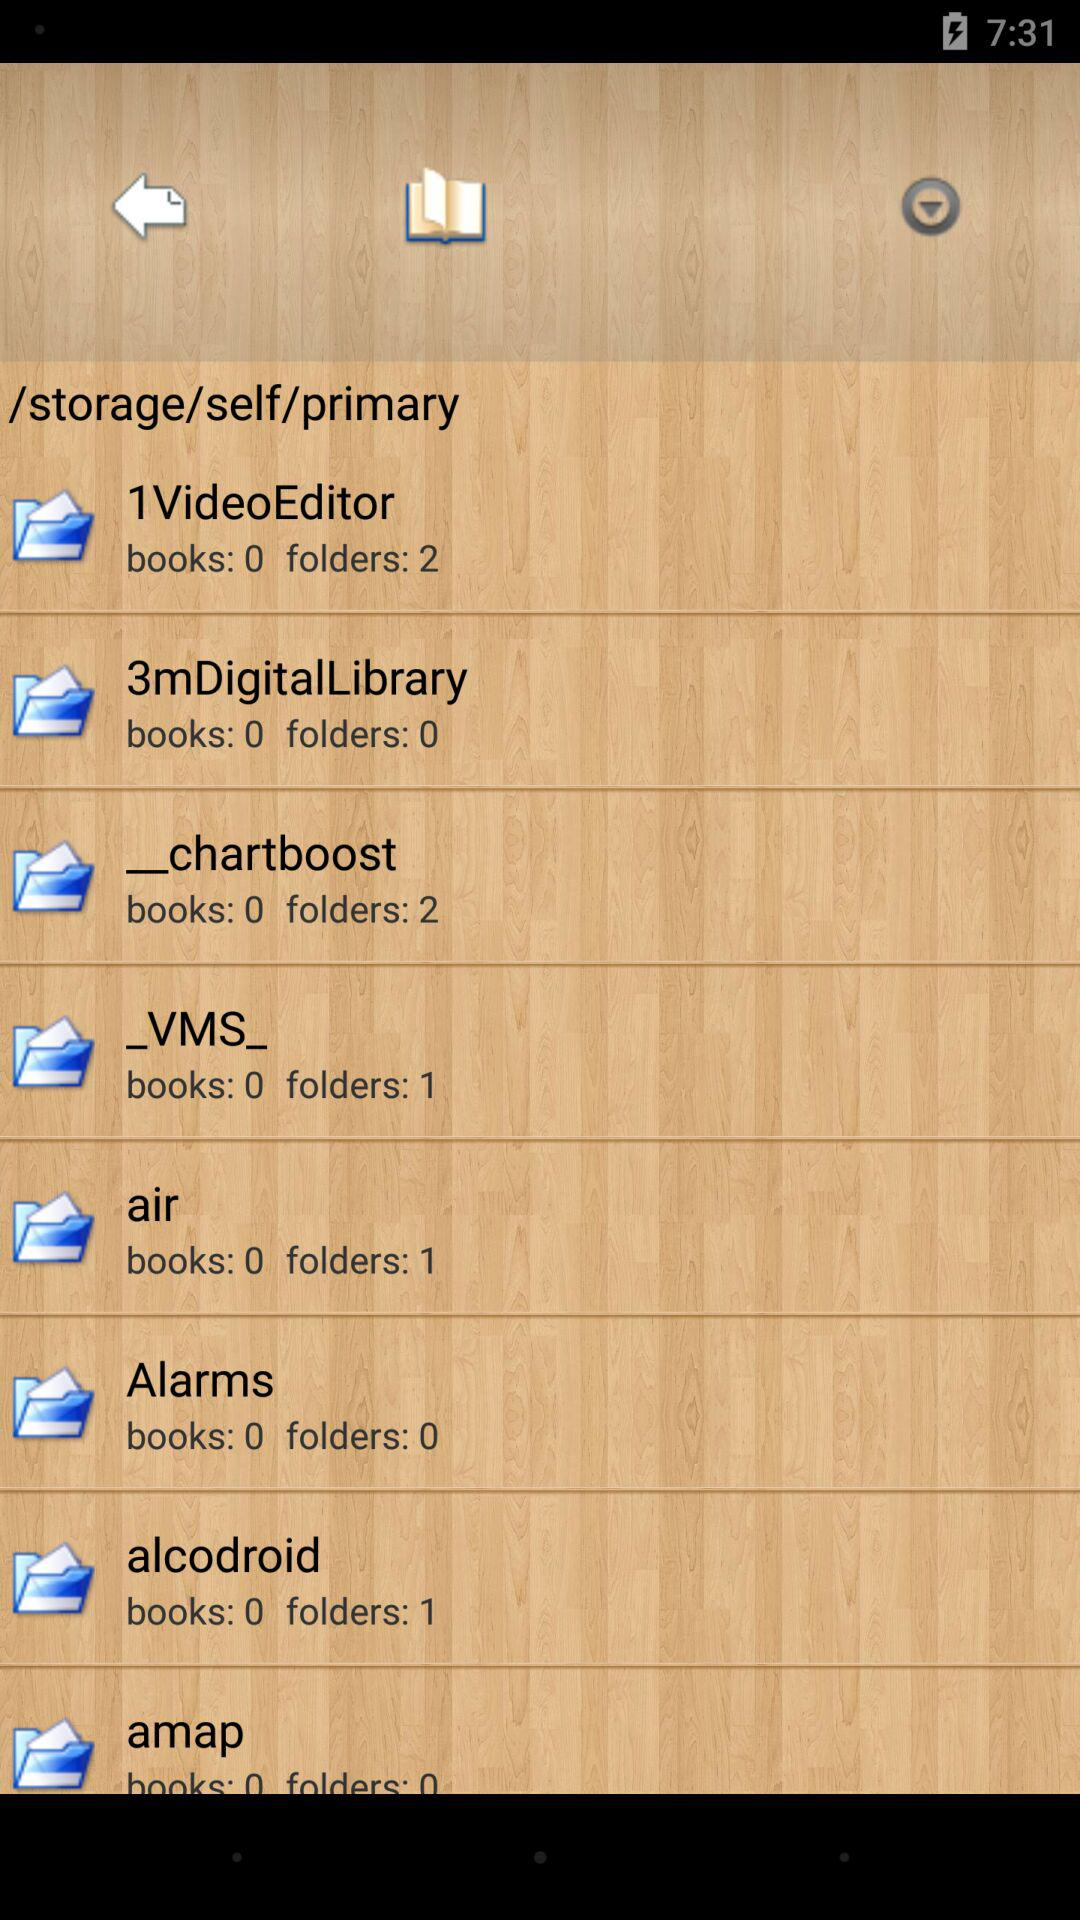Which file has the maximum number of folders?
When the provided information is insufficient, respond with <no answer>. <no answer> 